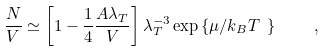<formula> <loc_0><loc_0><loc_500><loc_500>\frac { N } { V } \simeq \left [ 1 - \frac { 1 } { 4 } \frac { A \lambda _ { T } } { V } \right ] \lambda _ { T } ^ { - 3 } \exp \left \{ \mu / k _ { B } T \ \right \} \quad ,</formula> 